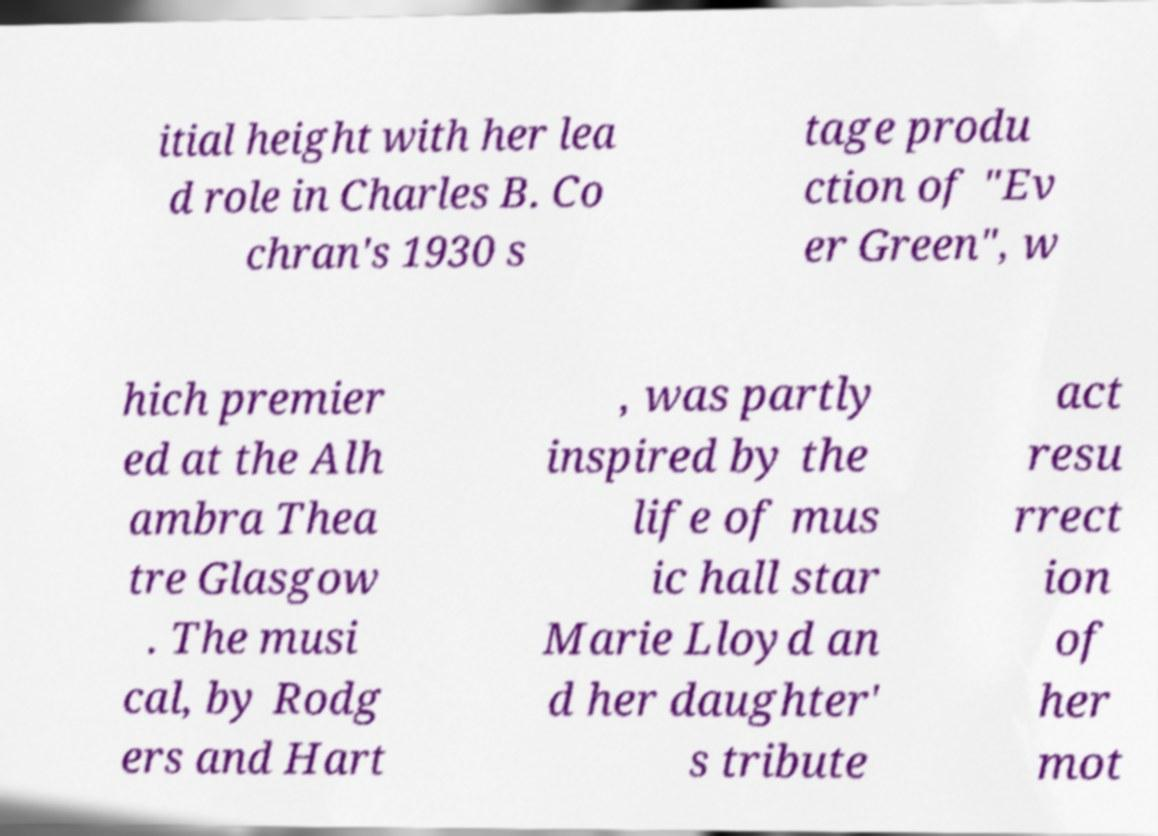There's text embedded in this image that I need extracted. Can you transcribe it verbatim? itial height with her lea d role in Charles B. Co chran's 1930 s tage produ ction of "Ev er Green", w hich premier ed at the Alh ambra Thea tre Glasgow . The musi cal, by Rodg ers and Hart , was partly inspired by the life of mus ic hall star Marie Lloyd an d her daughter' s tribute act resu rrect ion of her mot 